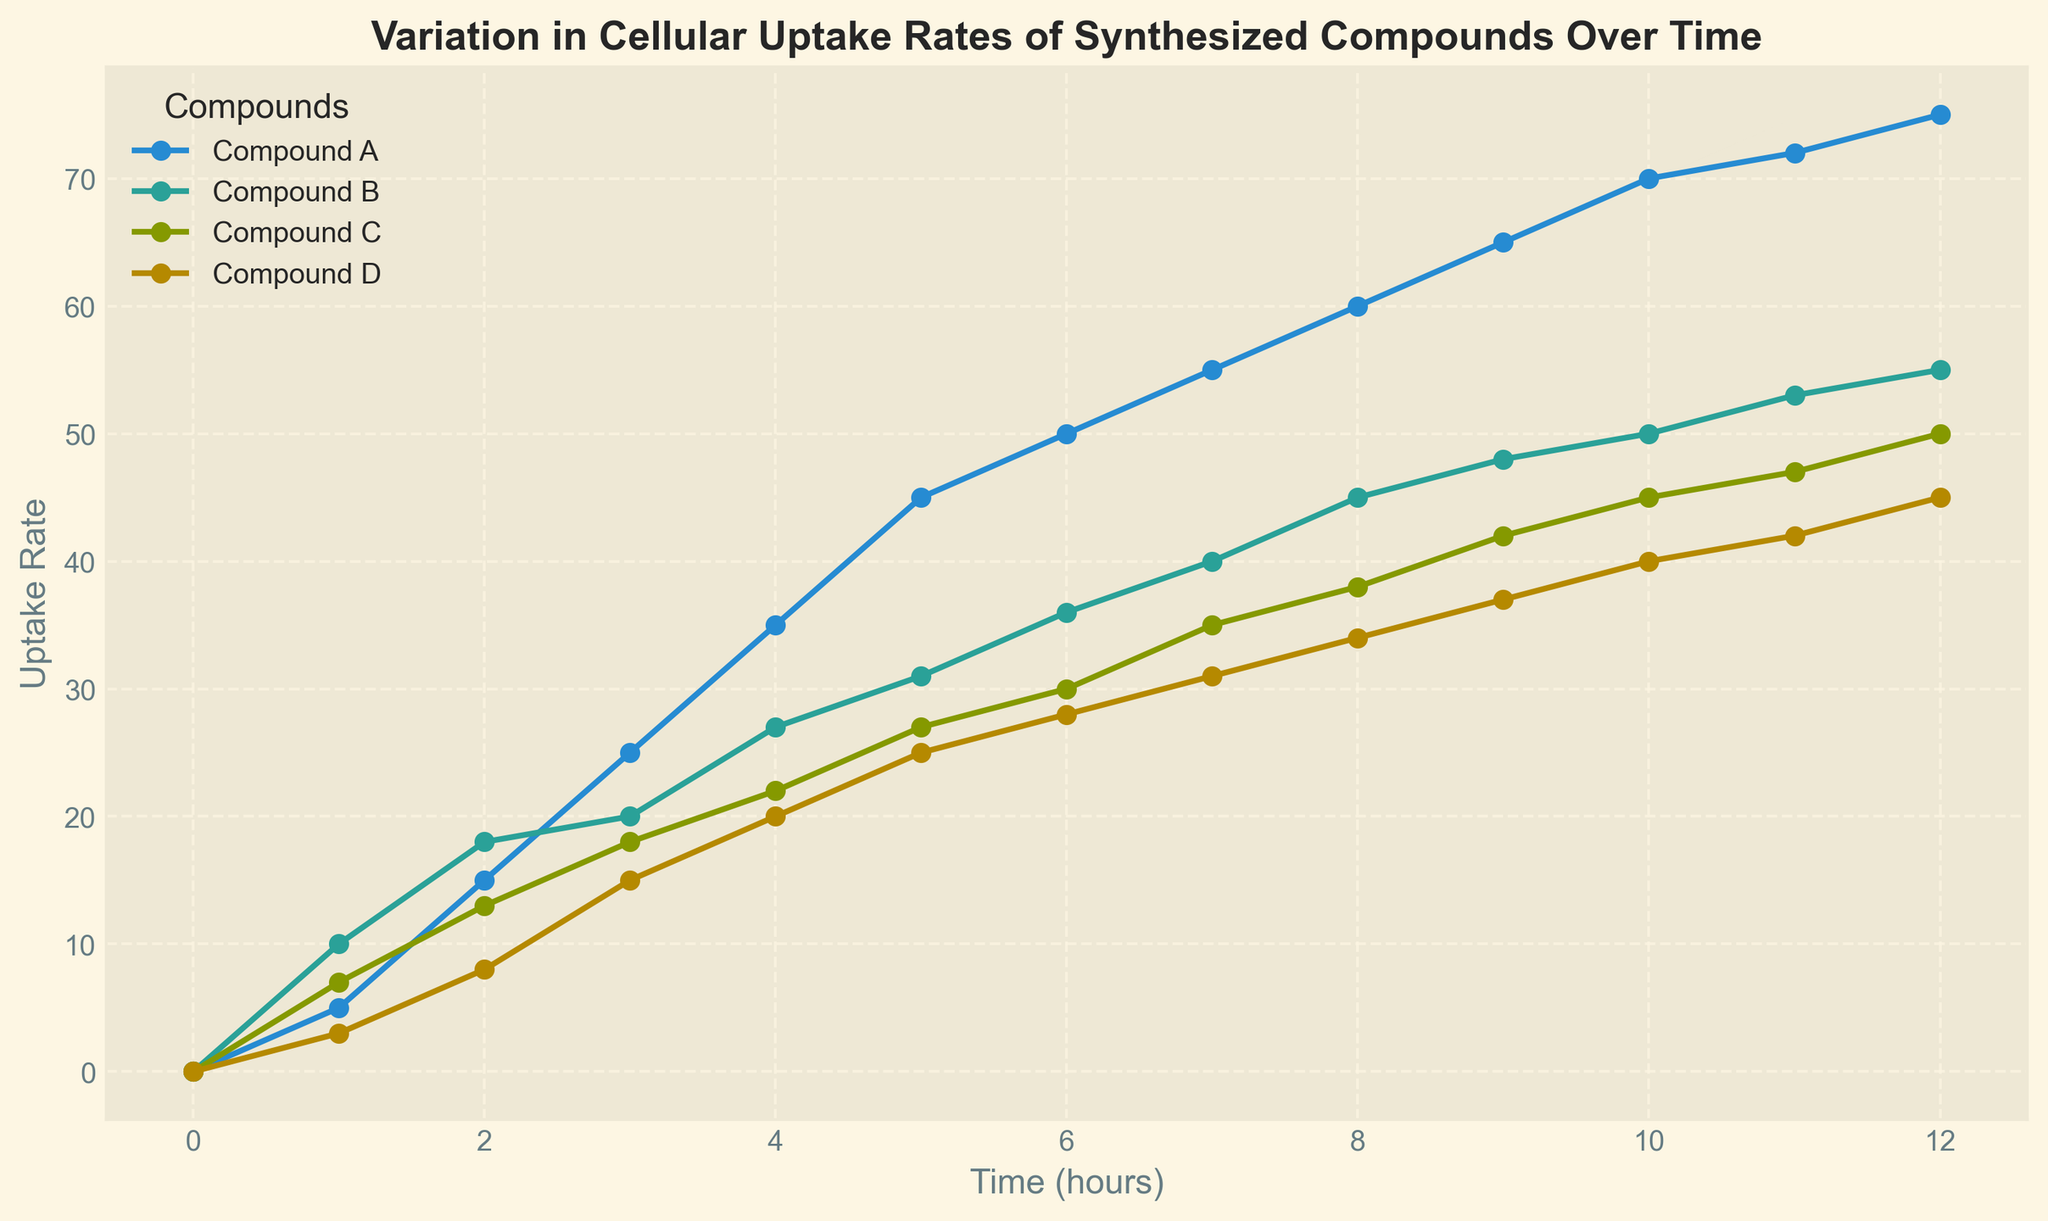What is the cellular uptake rate of Compound B at 4 hours? To find the cellular uptake rate of Compound B at 4 hours, locate the 4-hour mark on the x-axis and then see where the line for Compound B intersects this point vertically. According to the plot, the uptake rate for Compound B is 27 at 4 hours.
Answer: 27 How does the uptake rate of Compound C compare at 5 hours and 7 hours? To compare the uptake rates, check the values at 5 and 7 hours on the x-axis and follow the line for Compound C upwards. At 5 hours, it is 27, and at 7 hours, it is 35. So, the rate increases by 8 units.
Answer: Increases by 8 units Which compound shows the steepest increase in uptake rate from 0 to 1 hour? The steepest increase can be ascertained by comparing the slopes of the lines between 0 and 1 hour for all compounds. Compound B shows the steepest rise from 0 to 10, which is an increase of 10 units per hour.
Answer: Compound B What is the difference in uptake rate between Compound A and Compound D at 10 hours? At 10 hours, locate the points on the lines for Compound A and Compound D. Compound A has an uptake rate of 70, while Compound D has 40. The difference is 70 - 40 = 30.
Answer: 30 What is the average cellular uptake rate of Compound A over the first 6 hours? To find the average, sum the uptake rates of Compound A from 0 to 6 hours and divide by the number of data points: (0+5+15+25+35+45+50)/7 = 175/7 = 25.
Answer: 25 Which compound has a consistently lower uptake rate when compared to the others? Observing the plot, Compound D consistently shows the lowest uptake rate at each time point compared to Compounds A, B, and C.
Answer: Compound D How much does the uptake rate of Compound B change between 8 hours and 12 hours? Determine the uptake rates of Compound B at 8 hours (45) and 12 hours (55), then calculate the change: 55 - 45 = 10.
Answer: 10 At what time do Compound A and Compound C have equal uptake rates? By observing the graph, find the point where the lines for Compound A and Compound C intersect. They appear to intersect around 10-11 hours. Let's zoom in; they intersect precisely at 11 hours where both rates are 72.
Answer: 11 hours Which compound reaches an uptake rate of 50 first, and at what time does this occur? Trace each compound's line to find when they first reach an uptake rate of 50. Compound A reaches 50 at about 6 hours.
Answer: Compound A at 6 hours 